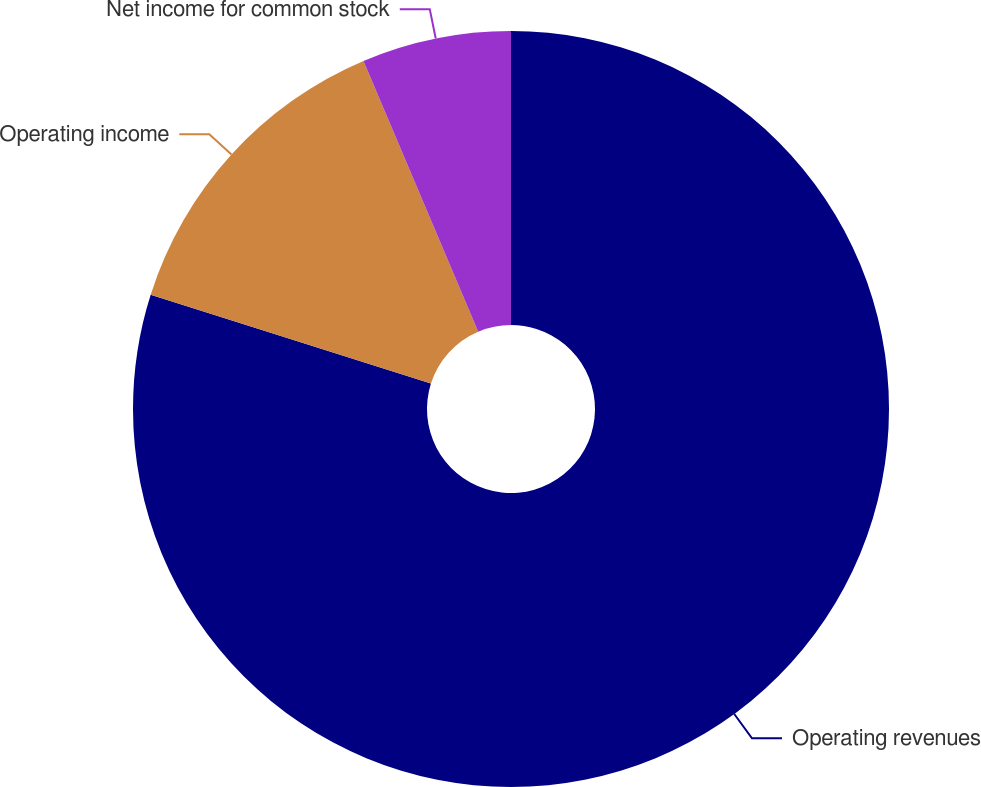Convert chart to OTSL. <chart><loc_0><loc_0><loc_500><loc_500><pie_chart><fcel>Operating revenues<fcel>Operating income<fcel>Net income for common stock<nl><fcel>79.88%<fcel>13.73%<fcel>6.38%<nl></chart> 